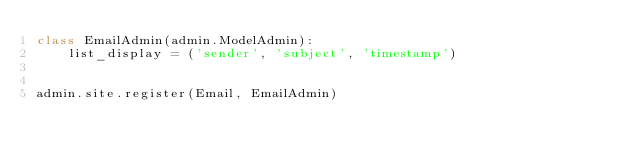Convert code to text. <code><loc_0><loc_0><loc_500><loc_500><_Python_>class EmailAdmin(admin.ModelAdmin):
    list_display = ('sender', 'subject', 'timestamp')


admin.site.register(Email, EmailAdmin)
</code> 